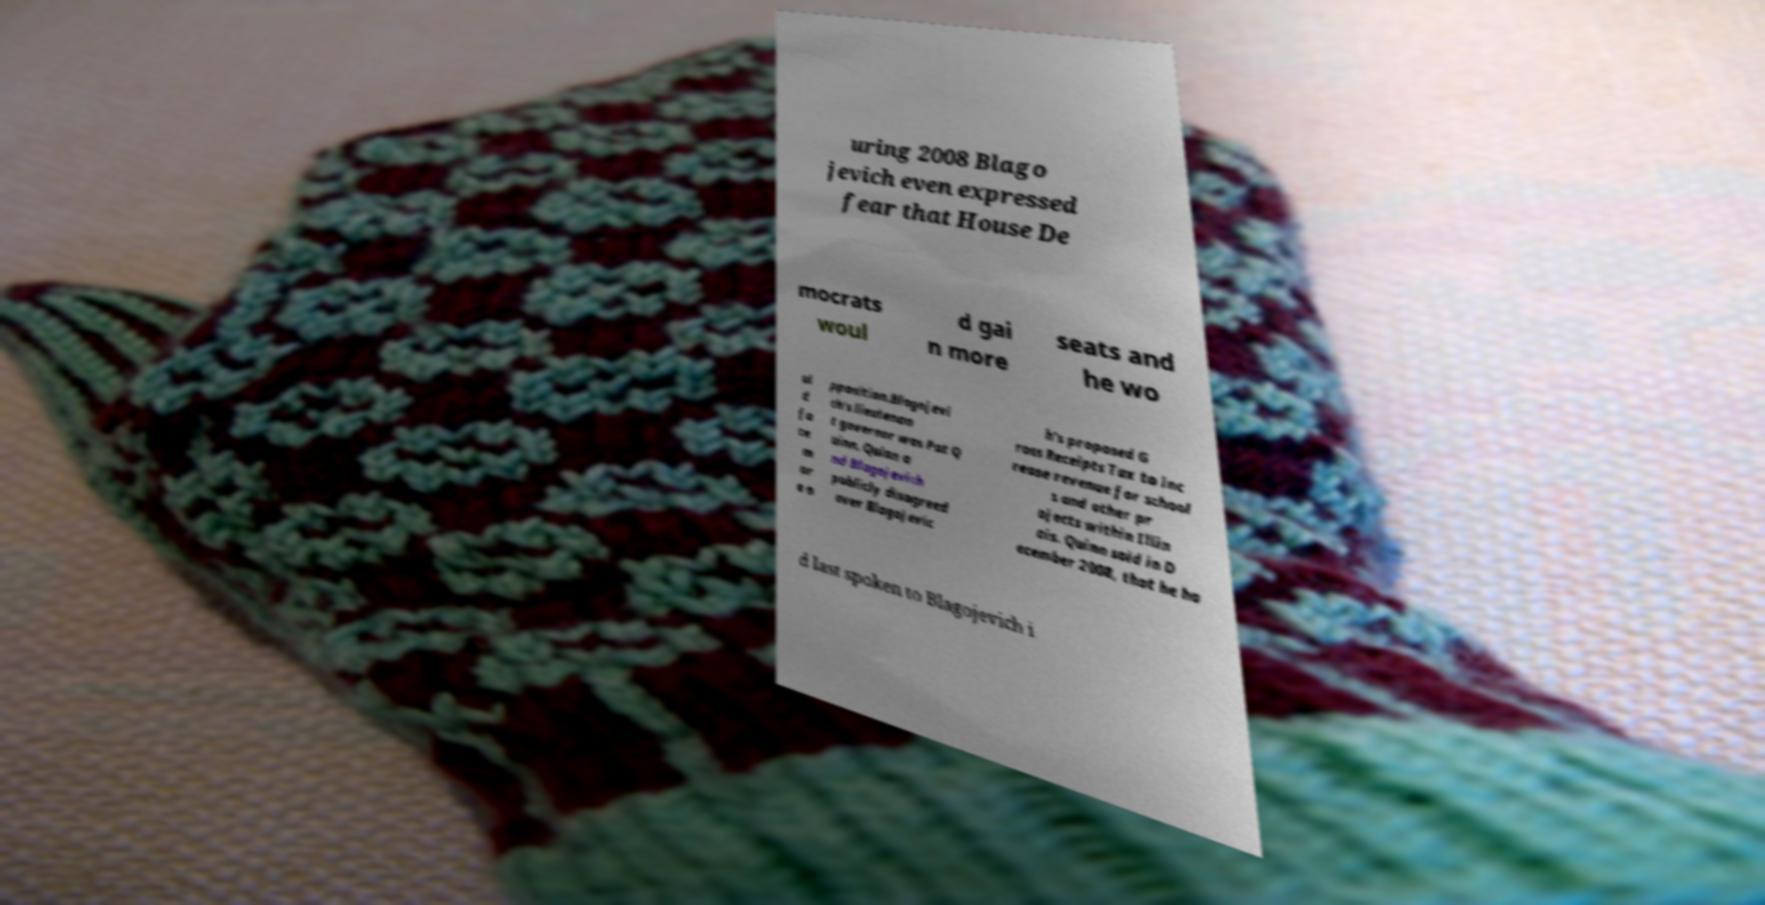Could you assist in decoding the text presented in this image and type it out clearly? uring 2008 Blago jevich even expressed fear that House De mocrats woul d gai n more seats and he wo ul d fa ce m or e o pposition.Blagojevi ch's lieutenan t governor was Pat Q uinn. Quinn a nd Blagojevich publicly disagreed over Blagojevic h's proposed G ross Receipts Tax to inc rease revenue for school s and other pr ojects within Illin ois. Quinn said in D ecember 2008, that he ha d last spoken to Blagojevich i 